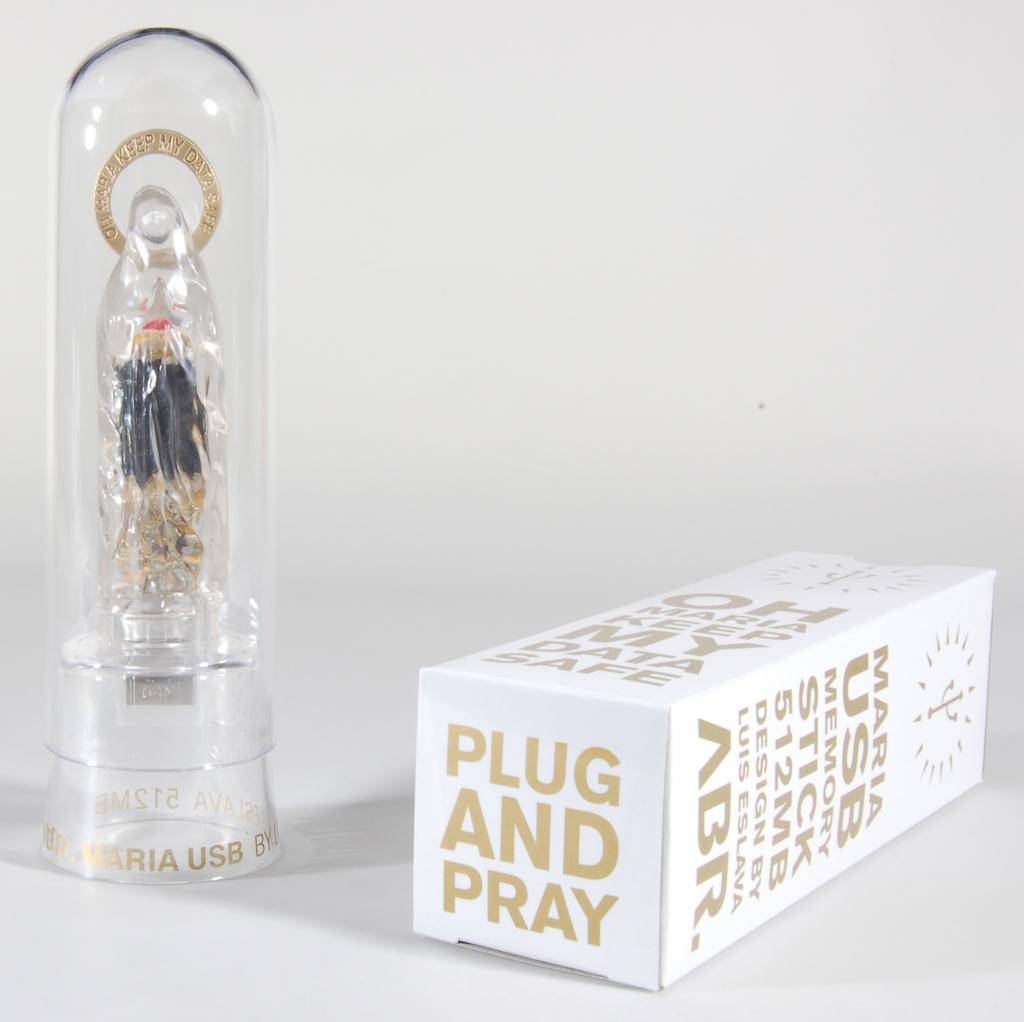<image>
Present a compact description of the photo's key features. A Saint Mary USB 512 MB memory stick in a clear container. 